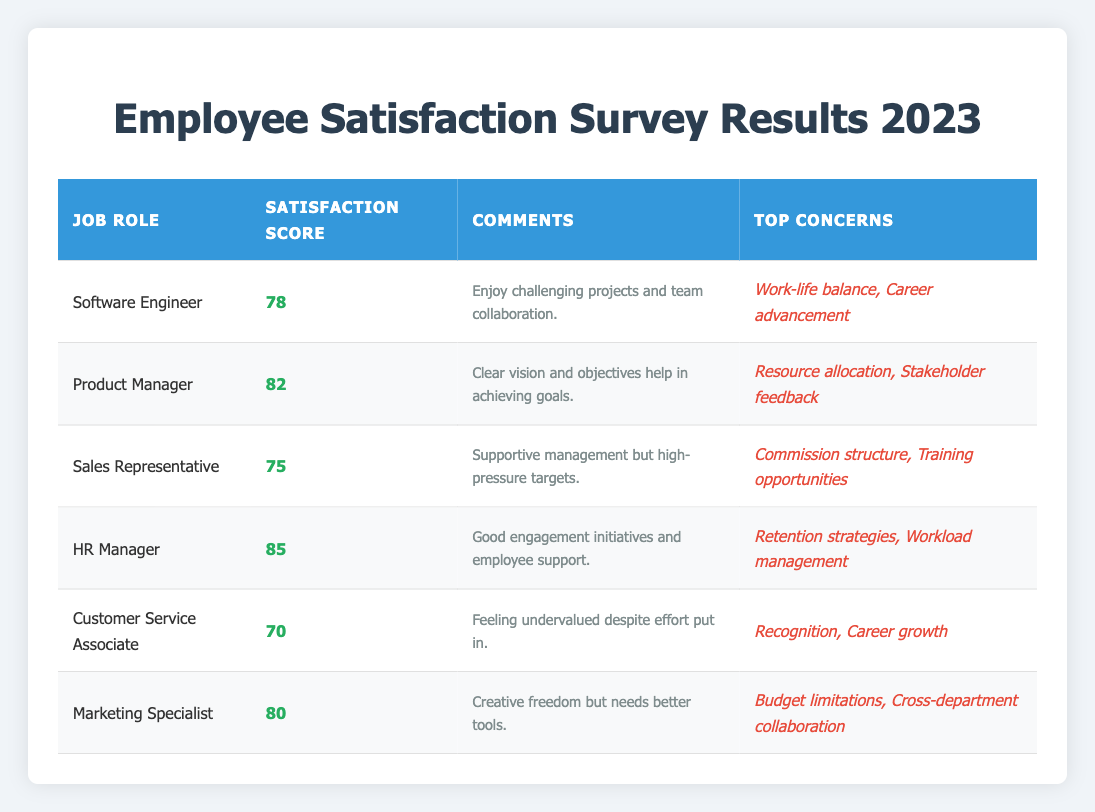What is the satisfaction score of the HR Manager? The satisfaction score for the HR Manager is listed directly in the table under the "Satisfaction Score" column for that job role. It is 85.
Answer: 85 What are the top concerns for Software Engineers? The top concerns for Software Engineers are listed in the "Top Concerns" column. They are "Work-life balance" and "Career advancement."
Answer: Work-life balance, Career advancement Which job role has the highest satisfaction score? By comparing the "Satisfaction Score" column across all job roles, the HR Manager has the highest score of 85.
Answer: HR Manager What is the average satisfaction score across all roles? To find the average, add the satisfaction scores: 78 + 82 + 75 + 85 + 70 + 80 = 470. Then divide by the number of roles (6): 470 / 6 = 78.33.
Answer: 78.33 Is the satisfaction score of the Marketing Specialist higher than that of the Sales Representative? From the table, the Marketing Specialist has a score of 80, while the Sales Representative has 75. Since 80 is greater than 75, the statement is true.
Answer: Yes How many job roles have a satisfaction score below 80? By checking the "Satisfaction Score" column, the following roles have scores below 80: Software Engineer (78), Sales Representative (75), Customer Service Associate (70). This amounts to three job roles.
Answer: 3 Do Customer Service Associates feel undervalued according to the comments? The comments provided for Customer Service Associates state they feel "undervalued despite effort put in," confirming this feeling.
Answer: Yes What is the total number of top concerns mentioned for all job roles? By looking at the "Top Concerns" column for each role, we find the following: Software Engineer (2), Product Manager (2), Sales Representative (2), HR Manager (2), Customer Service Associate (2), Marketing Specialist (2) – total = 12 concerns mentioned across all roles.
Answer: 12 What is the difference between the highest and lowest satisfaction scores? The highest satisfaction score is from HR Manager at 85, and the lowest is from Customer Service Associate at 70. Therefore, the difference is 85 - 70 = 15.
Answer: 15 